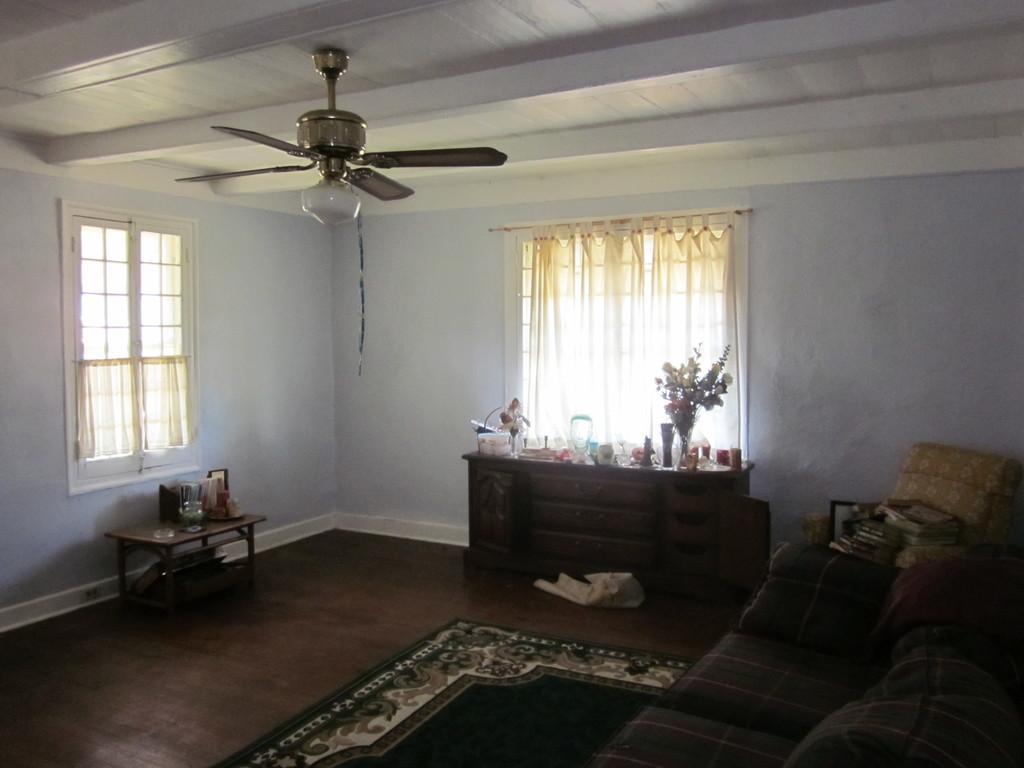Please provide a concise description of this image. On the right we can see couch. In the center there is a table,carpet,cloth. On table we can see flower vase,mug,toy,basket and doll. In the background there is a curtain,window,wall,fan,chair and books. 